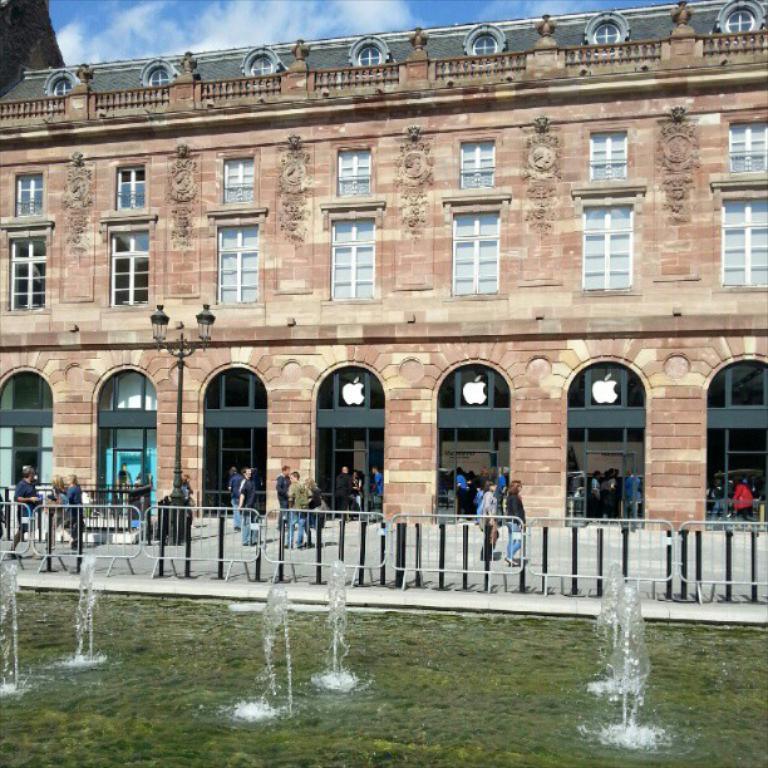Please provide a concise description of this image. In this image there are fountains in the center. In the background there are persons, there is fence and there is a building. In front of the building there is a light pole and the sky is cloudy and the persons are walking, standing. 